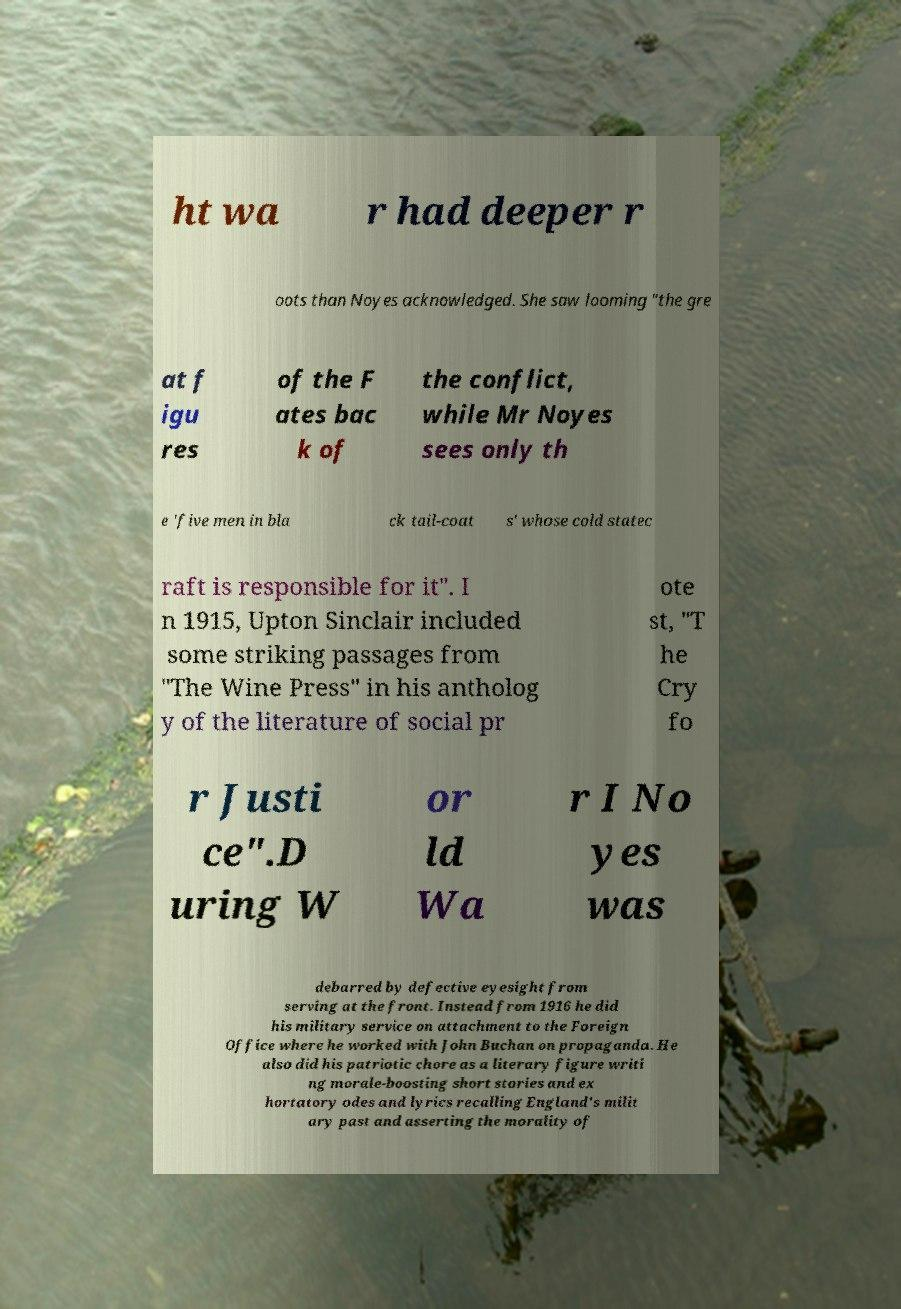For documentation purposes, I need the text within this image transcribed. Could you provide that? ht wa r had deeper r oots than Noyes acknowledged. She saw looming "the gre at f igu res of the F ates bac k of the conflict, while Mr Noyes sees only th e 'five men in bla ck tail-coat s' whose cold statec raft is responsible for it". I n 1915, Upton Sinclair included some striking passages from "The Wine Press" in his antholog y of the literature of social pr ote st, "T he Cry fo r Justi ce".D uring W or ld Wa r I No yes was debarred by defective eyesight from serving at the front. Instead from 1916 he did his military service on attachment to the Foreign Office where he worked with John Buchan on propaganda. He also did his patriotic chore as a literary figure writi ng morale-boosting short stories and ex hortatory odes and lyrics recalling England's milit ary past and asserting the morality of 